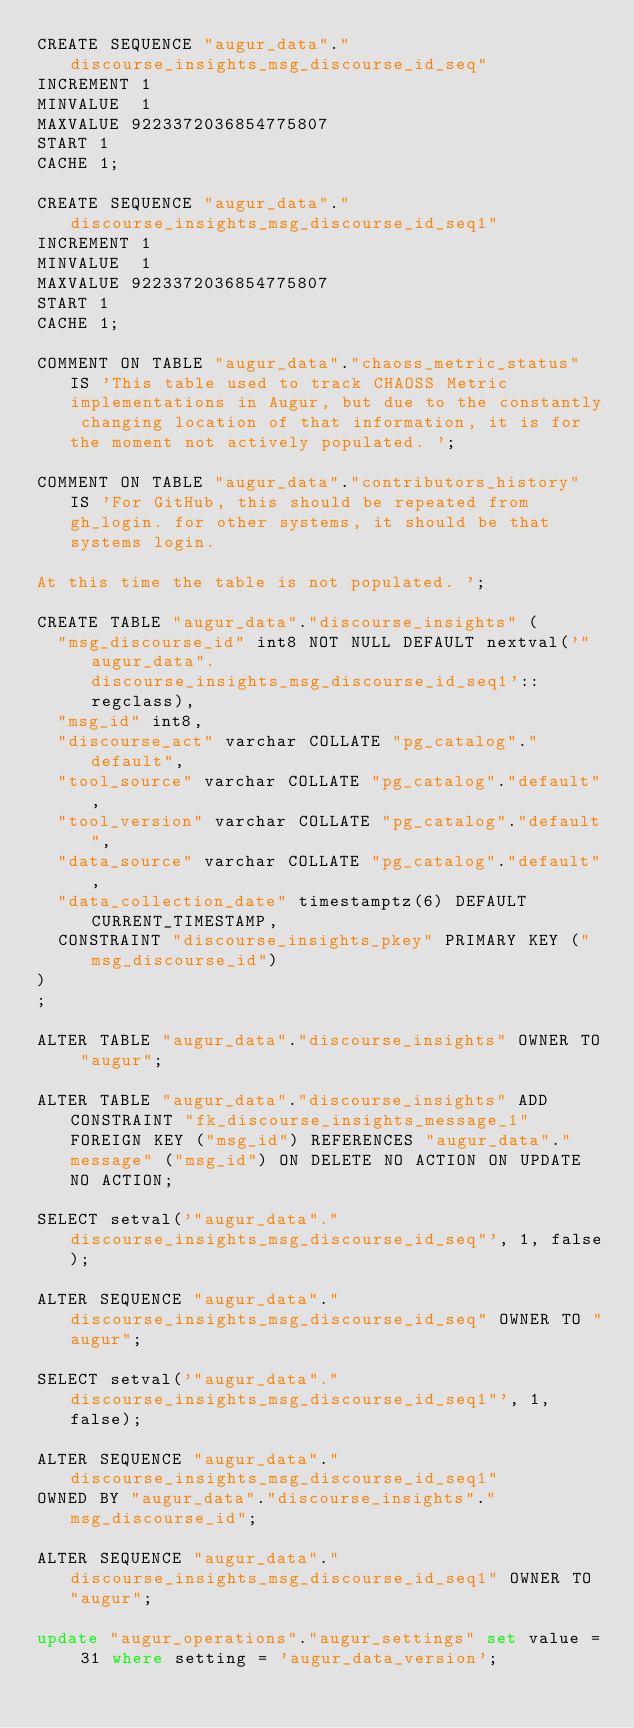Convert code to text. <code><loc_0><loc_0><loc_500><loc_500><_SQL_>CREATE SEQUENCE "augur_data"."discourse_insights_msg_discourse_id_seq" 
INCREMENT 1
MINVALUE  1
MAXVALUE 9223372036854775807
START 1
CACHE 1;

CREATE SEQUENCE "augur_data"."discourse_insights_msg_discourse_id_seq1" 
INCREMENT 1
MINVALUE  1
MAXVALUE 9223372036854775807
START 1
CACHE 1;

COMMENT ON TABLE "augur_data"."chaoss_metric_status" IS 'This table used to track CHAOSS Metric implementations in Augur, but due to the constantly changing location of that information, it is for the moment not actively populated. ';

COMMENT ON TABLE "augur_data"."contributors_history" IS 'For GitHub, this should be repeated from gh_login. for other systems, it should be that systems login. 

At this time the table is not populated. ';

CREATE TABLE "augur_data"."discourse_insights" (
  "msg_discourse_id" int8 NOT NULL DEFAULT nextval('"augur_data".discourse_insights_msg_discourse_id_seq1'::regclass),
  "msg_id" int8,
  "discourse_act" varchar COLLATE "pg_catalog"."default",
  "tool_source" varchar COLLATE "pg_catalog"."default",
  "tool_version" varchar COLLATE "pg_catalog"."default",
  "data_source" varchar COLLATE "pg_catalog"."default",
  "data_collection_date" timestamptz(6) DEFAULT CURRENT_TIMESTAMP,
  CONSTRAINT "discourse_insights_pkey" PRIMARY KEY ("msg_discourse_id")
)
;

ALTER TABLE "augur_data"."discourse_insights" OWNER TO "augur";

ALTER TABLE "augur_data"."discourse_insights" ADD CONSTRAINT "fk_discourse_insights_message_1" FOREIGN KEY ("msg_id") REFERENCES "augur_data"."message" ("msg_id") ON DELETE NO ACTION ON UPDATE NO ACTION;

SELECT setval('"augur_data"."discourse_insights_msg_discourse_id_seq"', 1, false);

ALTER SEQUENCE "augur_data"."discourse_insights_msg_discourse_id_seq" OWNER TO "augur";

SELECT setval('"augur_data"."discourse_insights_msg_discourse_id_seq1"', 1, false);

ALTER SEQUENCE "augur_data"."discourse_insights_msg_discourse_id_seq1"
OWNED BY "augur_data"."discourse_insights"."msg_discourse_id";

ALTER SEQUENCE "augur_data"."discourse_insights_msg_discourse_id_seq1" OWNER TO "augur";

update "augur_operations"."augur_settings" set value = 31 where setting = 'augur_data_version'; 
</code> 